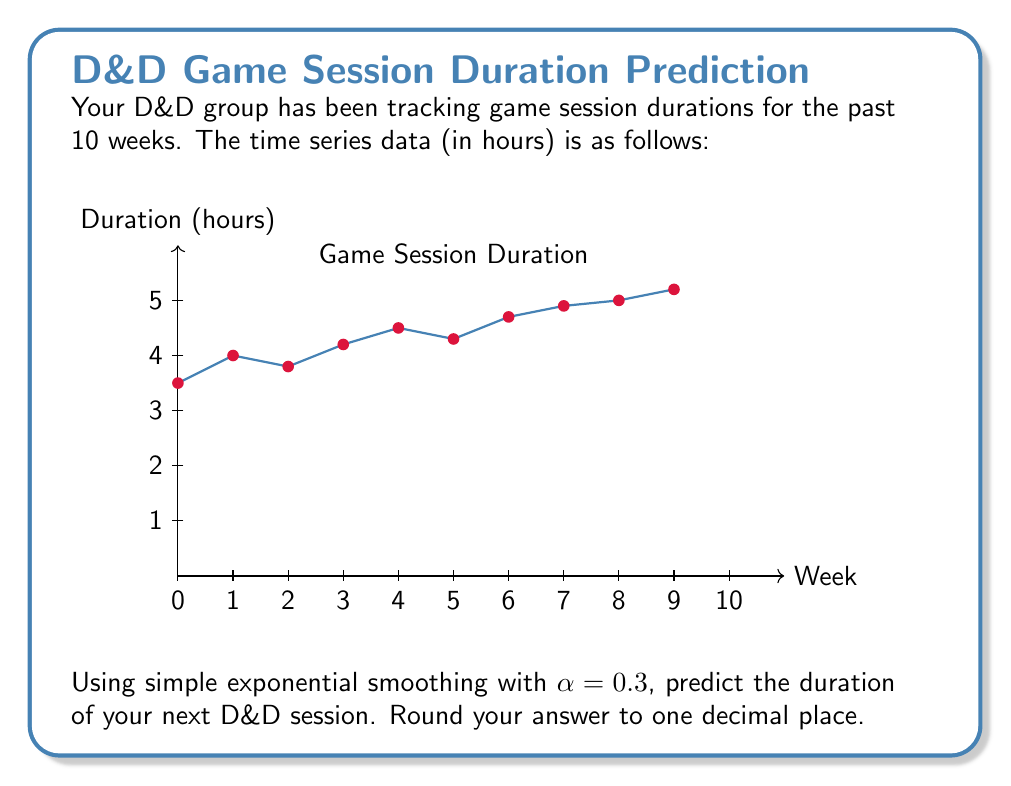What is the answer to this math problem? Let's approach this step-by-step:

1) Simple exponential smoothing is given by the formula:
   $$F_{t+1} = \alpha Y_t + (1-\alpha)F_t$$
   where $F_{t+1}$ is the forecast for the next period, $Y_t$ is the actual value at time $t$, and $F_t$ is the forecast for the current period.

2) We're given $\alpha = 0.3$. We need to start with an initial forecast. Typically, we use the first observed value as our initial forecast. So, $F_1 = 3.5$.

3) Let's calculate the forecasts for each period:

   $F_2 = 0.3(3.5) + 0.7(3.5) = 3.5$
   $F_3 = 0.3(4.0) + 0.7(3.5) = 3.65$
   $F_4 = 0.3(3.8) + 0.7(3.65) = 3.695$
   $F_5 = 0.3(4.2) + 0.7(3.695) = 3.8365$
   $F_6 = 0.3(4.5) + 0.7(3.8365) = 4.03555$
   $F_7 = 0.3(4.3) + 0.7(4.03555) = 4.124885$
   $F_8 = 0.3(4.7) + 0.7(4.124885) = 4.2874195$
   $F_9 = 0.3(4.9) + 0.7(4.2874195) = 4.4711937$
   $F_{10} = 0.3(5.0) + 0.7(4.4711937) = 4.6298356$

4) The forecast for the next session (week 11) is:
   $$F_{11} = 0.3(5.2) + 0.7(4.6298356) = 4.8008849$$

5) Rounding to one decimal place: 4.8 hours.
Answer: 4.8 hours 